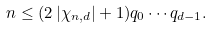<formula> <loc_0><loc_0><loc_500><loc_500>n \leq ( 2 \left | \chi _ { n , d } \right | + 1 ) q _ { 0 } \cdots q _ { d - 1 } .</formula> 